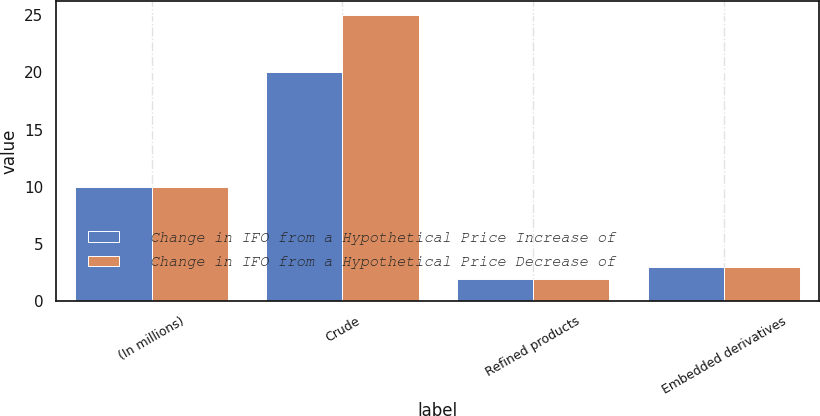<chart> <loc_0><loc_0><loc_500><loc_500><stacked_bar_chart><ecel><fcel>(In millions)<fcel>Crude<fcel>Refined products<fcel>Embedded derivatives<nl><fcel>Change in IFO from a Hypothetical Price Increase of<fcel>10<fcel>20<fcel>2<fcel>3<nl><fcel>Change in IFO from a Hypothetical Price Decrease of<fcel>10<fcel>25<fcel>2<fcel>3<nl></chart> 